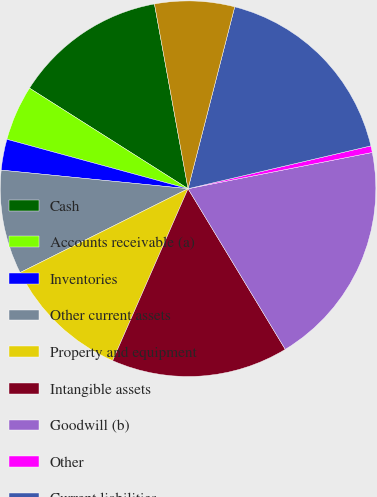Convert chart to OTSL. <chart><loc_0><loc_0><loc_500><loc_500><pie_chart><fcel>Cash<fcel>Accounts receivable (a)<fcel>Inventories<fcel>Other current assets<fcel>Property and equipment<fcel>Intangible assets<fcel>Goodwill (b)<fcel>Other<fcel>Current liabilities<fcel>Long-term liabilities<nl><fcel>13.14%<fcel>4.76%<fcel>2.66%<fcel>8.95%<fcel>11.05%<fcel>15.24%<fcel>19.43%<fcel>0.57%<fcel>17.34%<fcel>6.86%<nl></chart> 